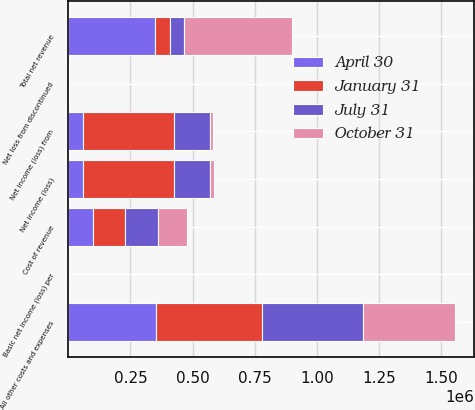Convert chart to OTSL. <chart><loc_0><loc_0><loc_500><loc_500><stacked_bar_chart><ecel><fcel>Total net revenue<fcel>Cost of revenue<fcel>All other costs and expenses<fcel>Net income (loss) from<fcel>Net loss from discontinued<fcel>Net income (loss)<fcel>Basic net income (loss) per<nl><fcel>April 30<fcel>350493<fcel>98207<fcel>350805<fcel>57200<fcel>1730<fcel>58930<fcel>0.17<nl><fcel>July 31<fcel>58065<fcel>131454<fcel>404466<fcel>145580<fcel>218<fcel>145362<fcel>0.42<nl><fcel>January 31<fcel>58065<fcel>130982<fcel>430083<fcel>367947<fcel>736<fcel>367211<fcel>1.08<nl><fcel>October 31<fcel>432672<fcel>117877<fcel>371503<fcel>12859<fcel>781<fcel>13640<fcel>0.04<nl></chart> 